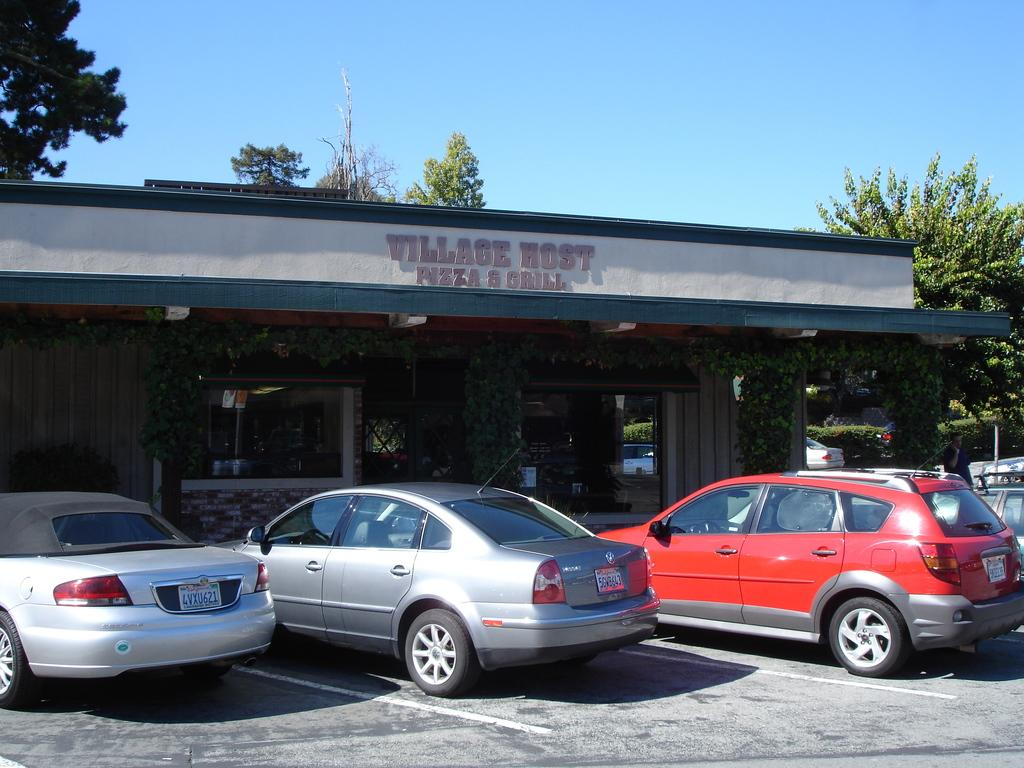What can be seen in front of the building in the image? There are cars parked in front of the building. What type of plants are growing on the wall? There are creeper plants on the wall. What type of vegetation is present in the image? There are trees and plants in the image. What part of the natural environment is visible in the image? The sky is visible in the image. What type of orange is being served in a bowl of soup in the image? There is no orange or soup present in the image. What time of day is depicted in the image? The time of day cannot be determined from the image, as there are no specific clues or indicators of the time of day. 